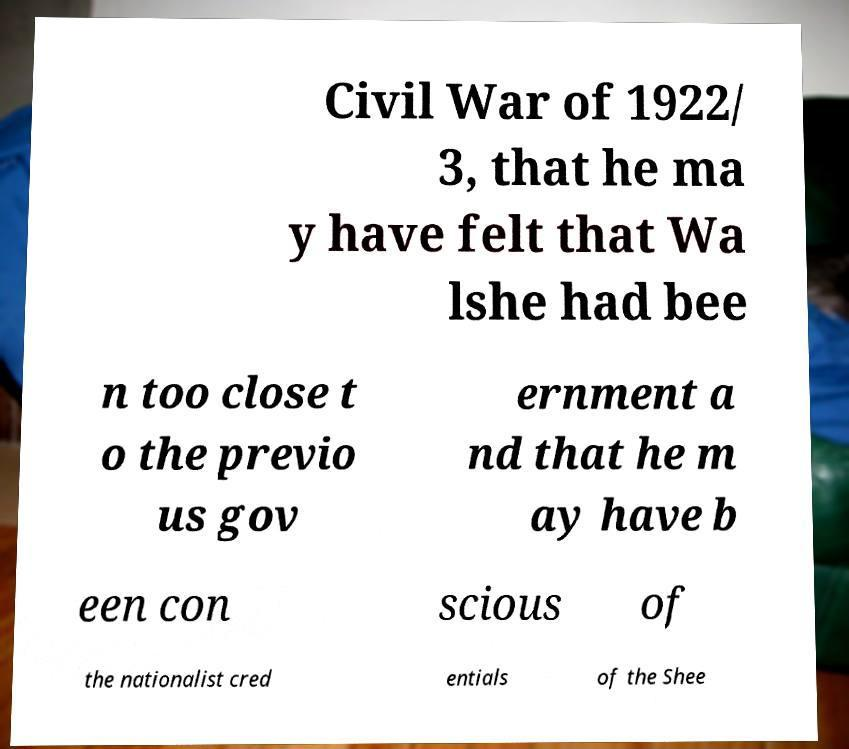Can you read and provide the text displayed in the image?This photo seems to have some interesting text. Can you extract and type it out for me? Civil War of 1922/ 3, that he ma y have felt that Wa lshe had bee n too close t o the previo us gov ernment a nd that he m ay have b een con scious of the nationalist cred entials of the Shee 